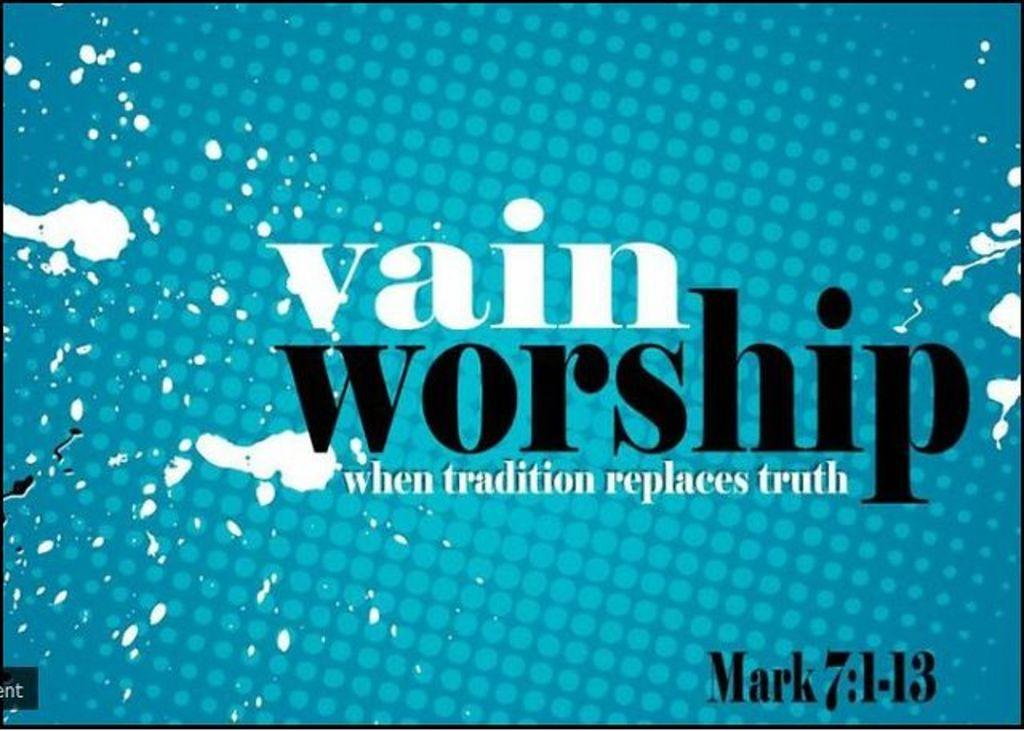<image>
Offer a succinct explanation of the picture presented. "Vain Worship" is written on this bible verse advert. 